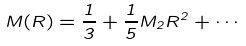Convert formula to latex. <formula><loc_0><loc_0><loc_500><loc_500>M ( R ) = \frac { 1 } { 3 } + \frac { 1 } { 5 } M _ { 2 } R ^ { 2 } + \cdots</formula> 